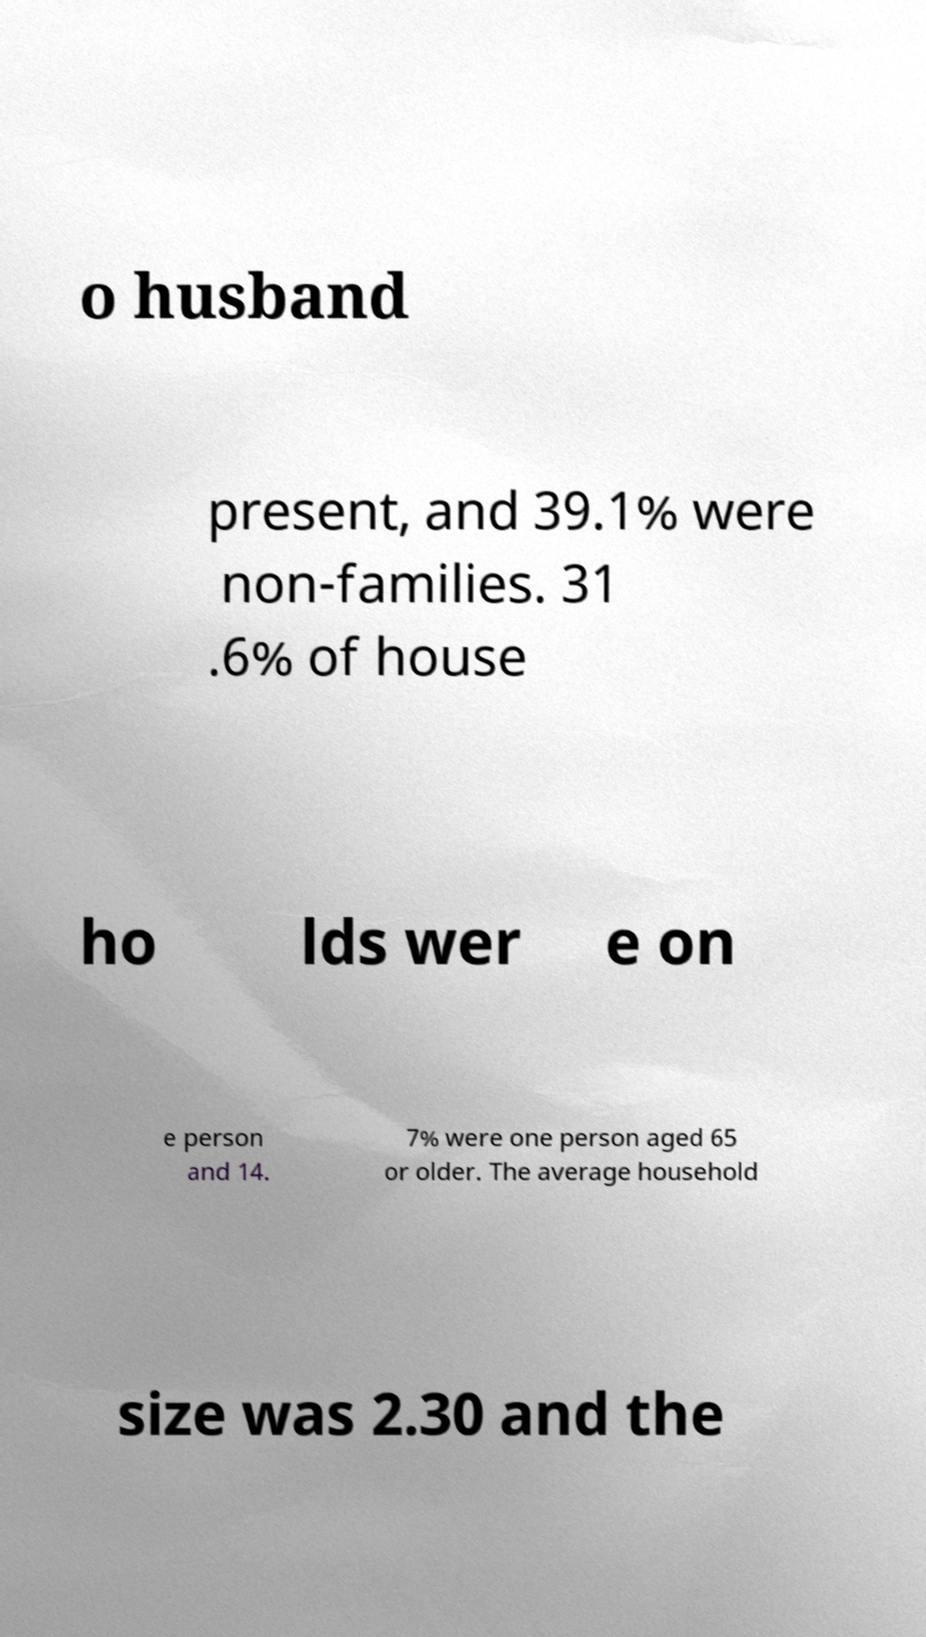Please identify and transcribe the text found in this image. o husband present, and 39.1% were non-families. 31 .6% of house ho lds wer e on e person and 14. 7% were one person aged 65 or older. The average household size was 2.30 and the 